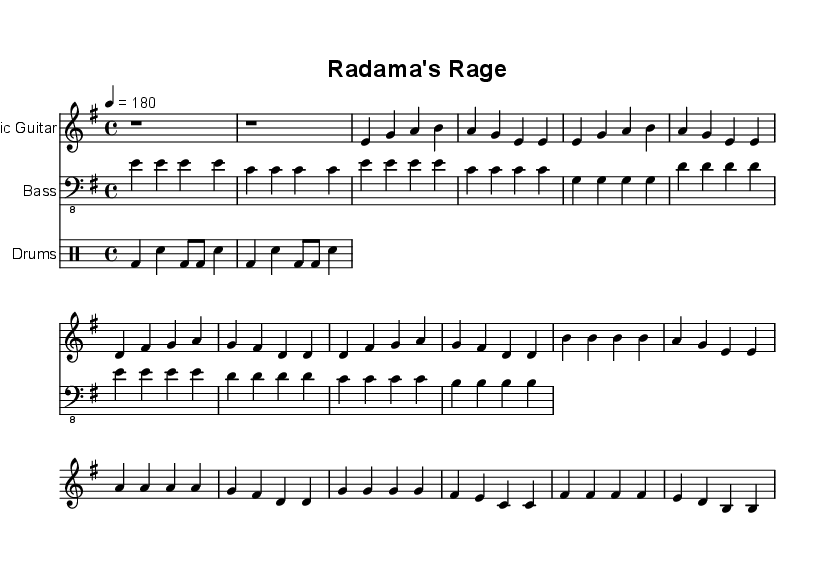What is the key signature of this music? The key signature is E minor, which has one sharp (F#). This is determined by identifying the key signature section of the sheet music, which indicates E minor is represented by a single sharp.
Answer: E minor What is the time signature of this music? The time signature is 4/4, which means there are four beats in each measure, with each beat represented by a quarter note. This is noted at the start of the score and is a common time signature in punk music.
Answer: 4/4 What is the tempo marking for this piece? The tempo marking is 4 equals 180, indicating that there should be 180 beats per minute. This is specified in the global section and highlights the fast-paced nature typical of punk music.
Answer: 180 How many measures are in the verse section? The verse section consists of four measures, which can be counted by analyzing the music notation in that section and identifying the number of measures present.
Answer: 4 Which instrument has the first part in the intro? The electric guitar has the first part in the intro, as it is the first staff listed in the score and starts the introduction with two rests.
Answer: Electric Guitar What type of beat is primarily used in the drums part? A basic punk beat is primarily used, characterized by the kick drum and snare pattern typically found in punk rock music. This can be identified through the drummode notation that outlines the rhythm.
Answer: Basic punk beat What is the ending note of the chorus section? The ending note of the chorus section is B, which can be determined by looking at the last measure of the chorus in the electric guitar part, where it concludes with a B note.
Answer: B 